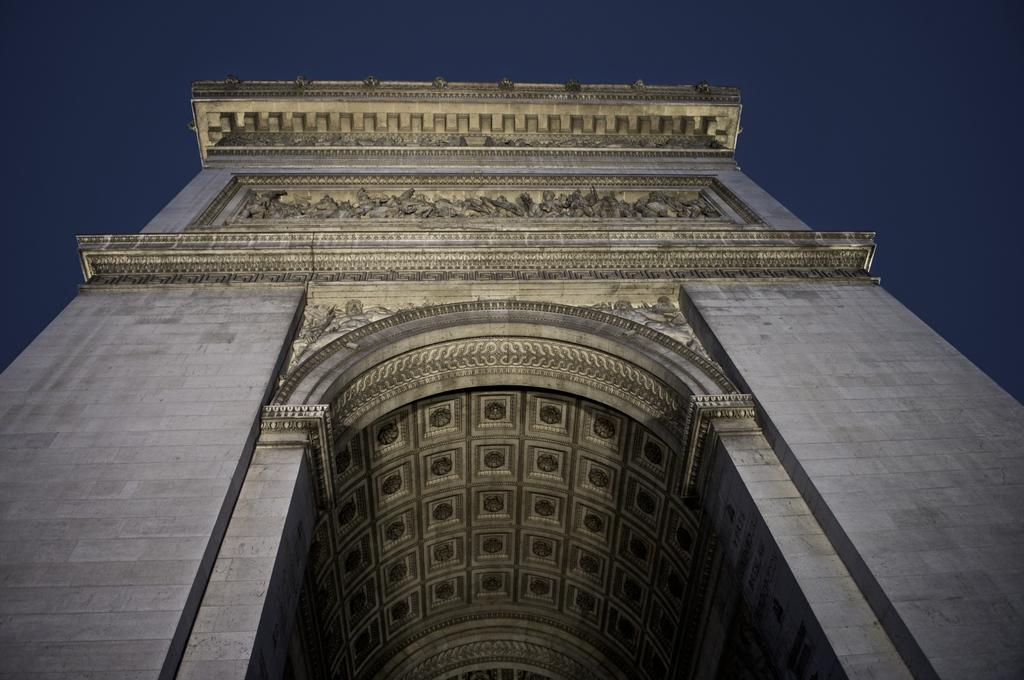What is the main structure in the image? There is a gateway in the image. What features can be seen on the gateway? The gateway has sculptures and designs on it. What part of the natural environment is visible in the image? The sky is visible in the image. What is the color of the sky in the image? The sky is blue in color. How many spoons can be seen hanging from the gateway in the image? There are no spoons present in the image, as it features a gateway with sculptures and designs. 